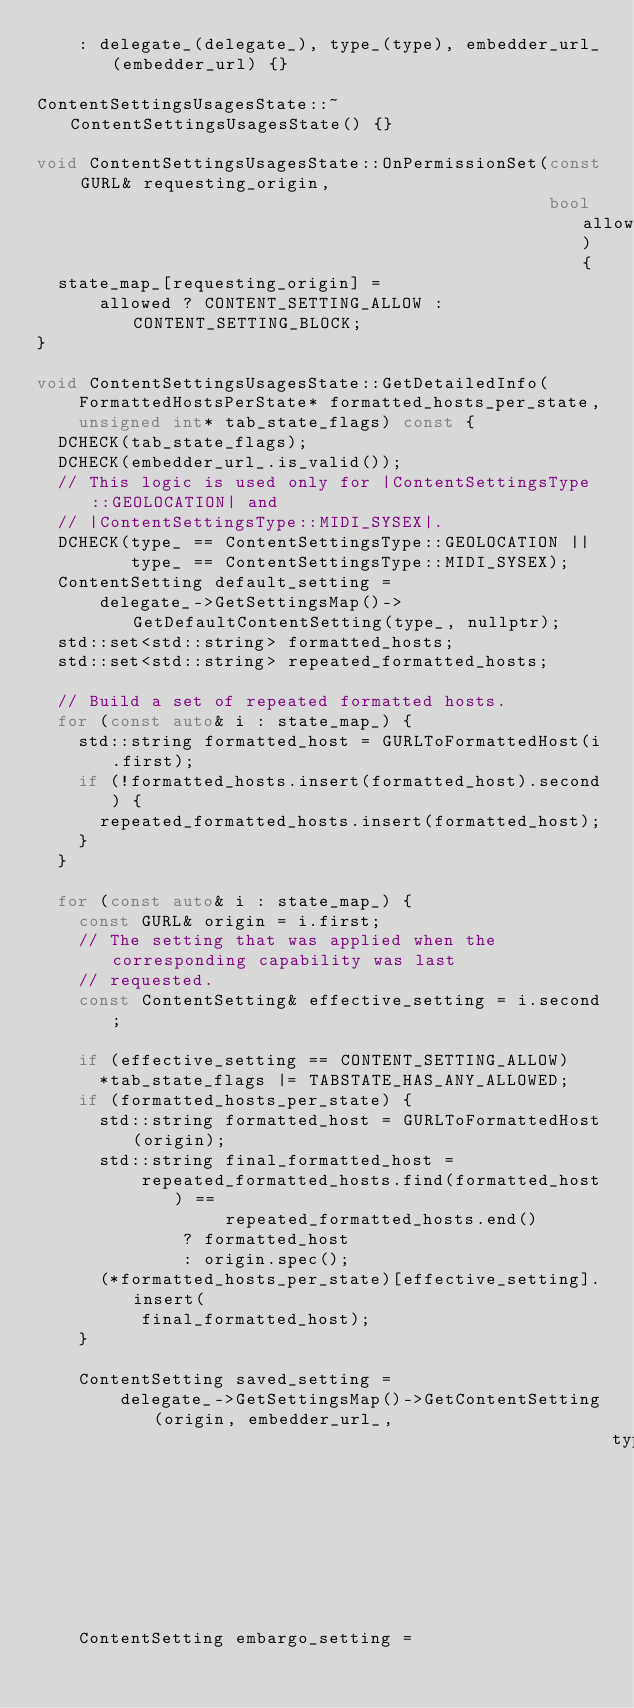<code> <loc_0><loc_0><loc_500><loc_500><_C++_>    : delegate_(delegate_), type_(type), embedder_url_(embedder_url) {}

ContentSettingsUsagesState::~ContentSettingsUsagesState() {}

void ContentSettingsUsagesState::OnPermissionSet(const GURL& requesting_origin,
                                                 bool allowed) {
  state_map_[requesting_origin] =
      allowed ? CONTENT_SETTING_ALLOW : CONTENT_SETTING_BLOCK;
}

void ContentSettingsUsagesState::GetDetailedInfo(
    FormattedHostsPerState* formatted_hosts_per_state,
    unsigned int* tab_state_flags) const {
  DCHECK(tab_state_flags);
  DCHECK(embedder_url_.is_valid());
  // This logic is used only for |ContentSettingsType::GEOLOCATION| and
  // |ContentSettingsType::MIDI_SYSEX|.
  DCHECK(type_ == ContentSettingsType::GEOLOCATION ||
         type_ == ContentSettingsType::MIDI_SYSEX);
  ContentSetting default_setting =
      delegate_->GetSettingsMap()->GetDefaultContentSetting(type_, nullptr);
  std::set<std::string> formatted_hosts;
  std::set<std::string> repeated_formatted_hosts;

  // Build a set of repeated formatted hosts.
  for (const auto& i : state_map_) {
    std::string formatted_host = GURLToFormattedHost(i.first);
    if (!formatted_hosts.insert(formatted_host).second) {
      repeated_formatted_hosts.insert(formatted_host);
    }
  }

  for (const auto& i : state_map_) {
    const GURL& origin = i.first;
    // The setting that was applied when the corresponding capability was last
    // requested.
    const ContentSetting& effective_setting = i.second;

    if (effective_setting == CONTENT_SETTING_ALLOW)
      *tab_state_flags |= TABSTATE_HAS_ANY_ALLOWED;
    if (formatted_hosts_per_state) {
      std::string formatted_host = GURLToFormattedHost(origin);
      std::string final_formatted_host =
          repeated_formatted_hosts.find(formatted_host) ==
                  repeated_formatted_hosts.end()
              ? formatted_host
              : origin.spec();
      (*formatted_hosts_per_state)[effective_setting].insert(
          final_formatted_host);
    }

    ContentSetting saved_setting =
        delegate_->GetSettingsMap()->GetContentSetting(origin, embedder_url_,
                                                       type_, std::string());
    ContentSetting embargo_setting =</code> 